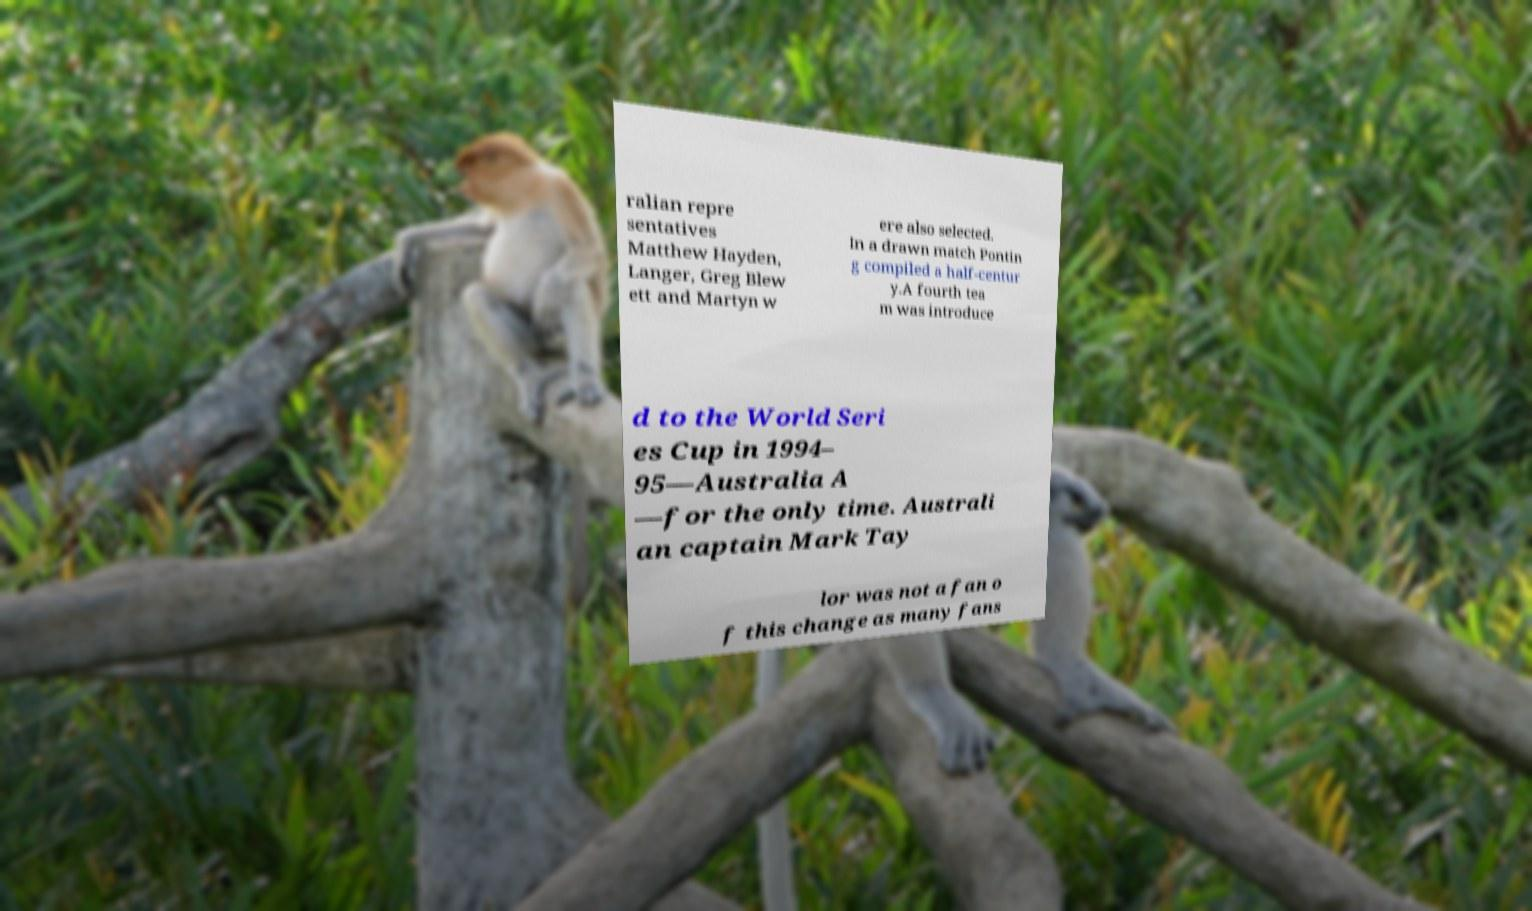What messages or text are displayed in this image? I need them in a readable, typed format. ralian repre sentatives Matthew Hayden, Langer, Greg Blew ett and Martyn w ere also selected. In a drawn match Pontin g compiled a half-centur y.A fourth tea m was introduce d to the World Seri es Cup in 1994– 95—Australia A —for the only time. Australi an captain Mark Tay lor was not a fan o f this change as many fans 